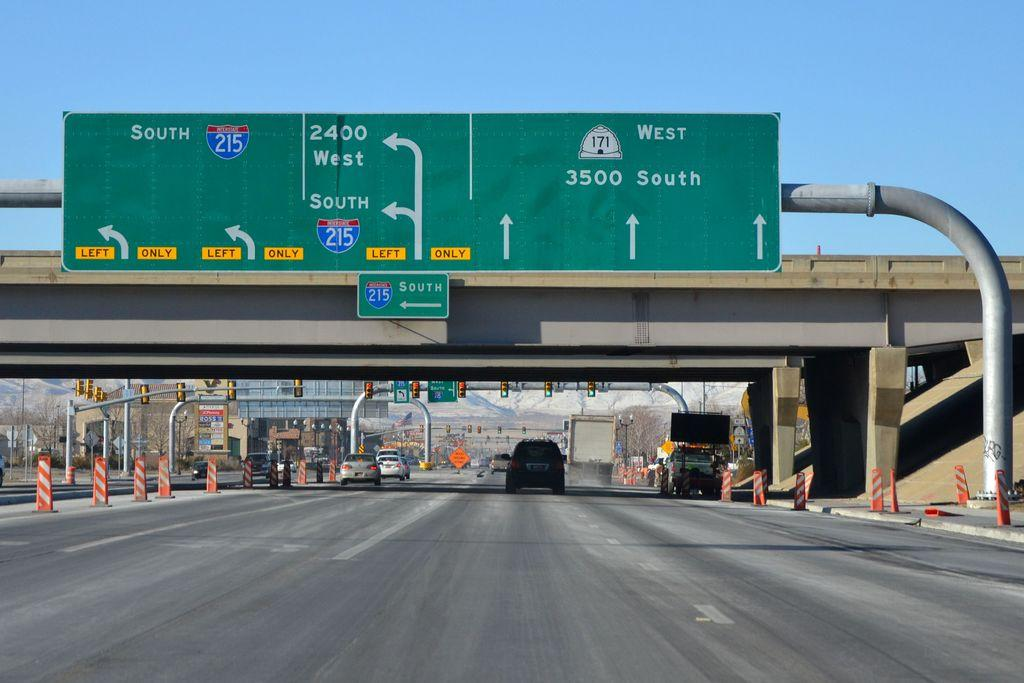<image>
Render a clear and concise summary of the photo. Highway signs on a road pointing straight ahead to West 171 and 3500 South 